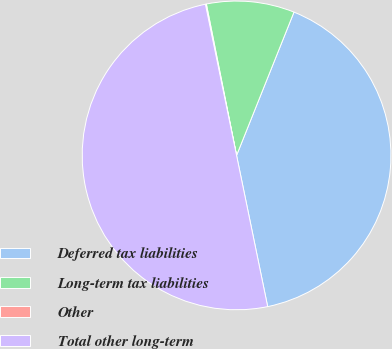Convert chart to OTSL. <chart><loc_0><loc_0><loc_500><loc_500><pie_chart><fcel>Deferred tax liabilities<fcel>Long-term tax liabilities<fcel>Other<fcel>Total other long-term<nl><fcel>40.71%<fcel>9.2%<fcel>0.1%<fcel>50.0%<nl></chart> 